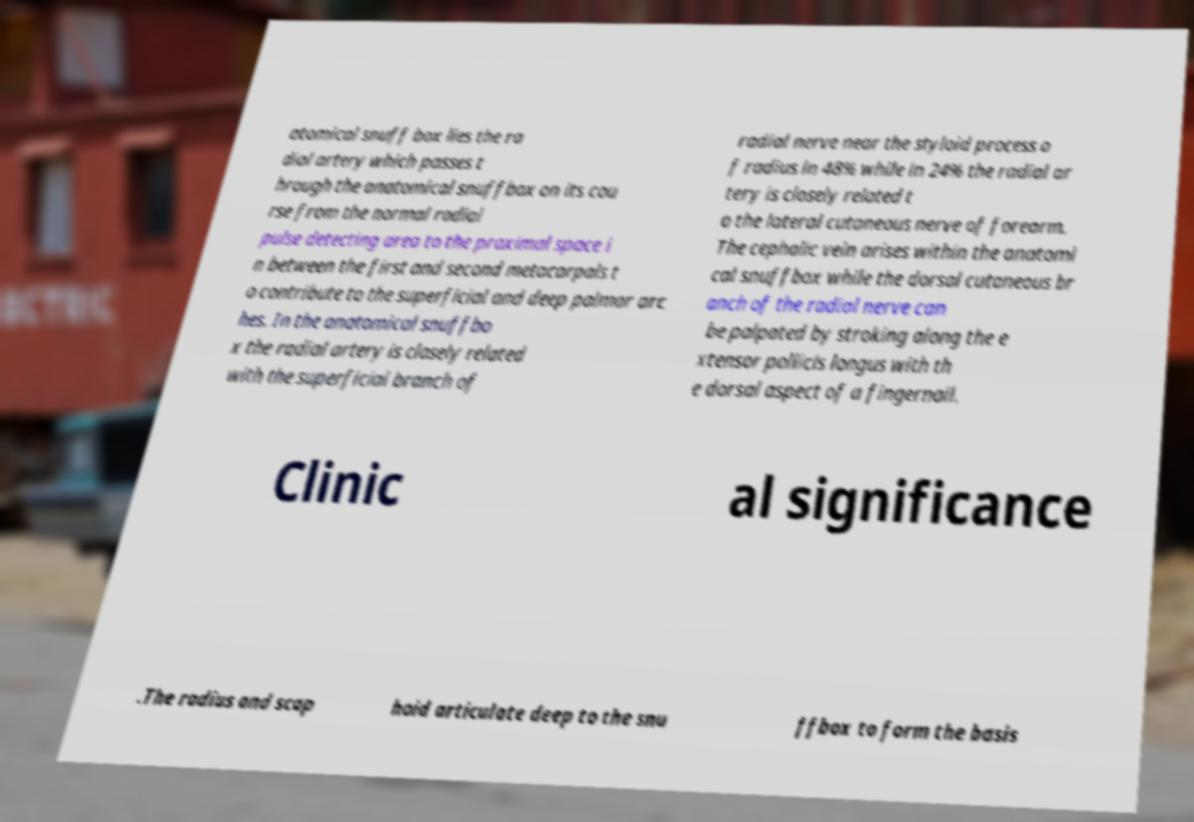Please read and relay the text visible in this image. What does it say? atomical snuff box lies the ra dial artery which passes t hrough the anatomical snuffbox on its cou rse from the normal radial pulse detecting area to the proximal space i n between the first and second metacarpals t o contribute to the superficial and deep palmar arc hes. In the anatomical snuffbo x the radial artery is closely related with the superficial branch of radial nerve near the styloid process o f radius in 48% while in 24% the radial ar tery is closely related t o the lateral cutaneous nerve of forearm. The cephalic vein arises within the anatomi cal snuffbox while the dorsal cutaneous br anch of the radial nerve can be palpated by stroking along the e xtensor pollicis longus with th e dorsal aspect of a fingernail. Clinic al significance .The radius and scap hoid articulate deep to the snu ffbox to form the basis 